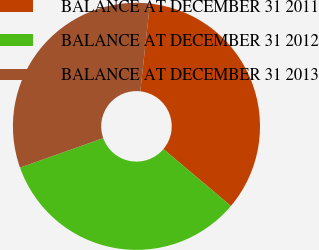<chart> <loc_0><loc_0><loc_500><loc_500><pie_chart><fcel>BALANCE AT DECEMBER 31 2011<fcel>BALANCE AT DECEMBER 31 2012<fcel>BALANCE AT DECEMBER 31 2013<nl><fcel>34.41%<fcel>33.43%<fcel>32.16%<nl></chart> 